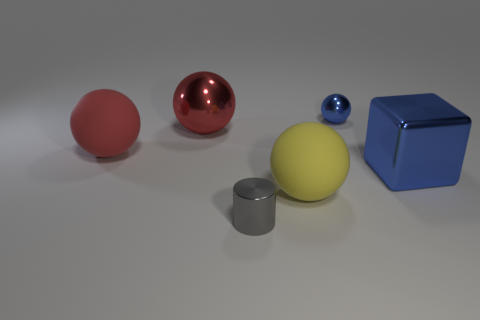Subtract all red balls. Subtract all green cylinders. How many balls are left? 2 Add 2 red matte balls. How many objects exist? 8 Subtract all cubes. How many objects are left? 5 Subtract 2 red spheres. How many objects are left? 4 Subtract all gray cubes. Subtract all tiny blue objects. How many objects are left? 5 Add 6 large red shiny balls. How many large red shiny balls are left? 7 Add 5 large blocks. How many large blocks exist? 6 